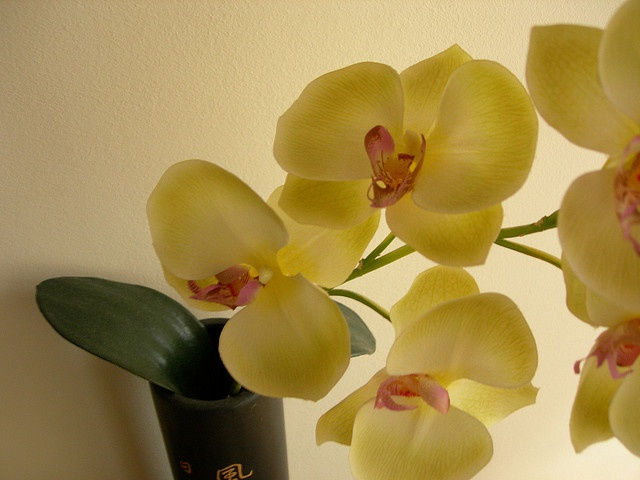Describe the objects in this image and their specific colors. I can see a vase in gray and black tones in this image. 